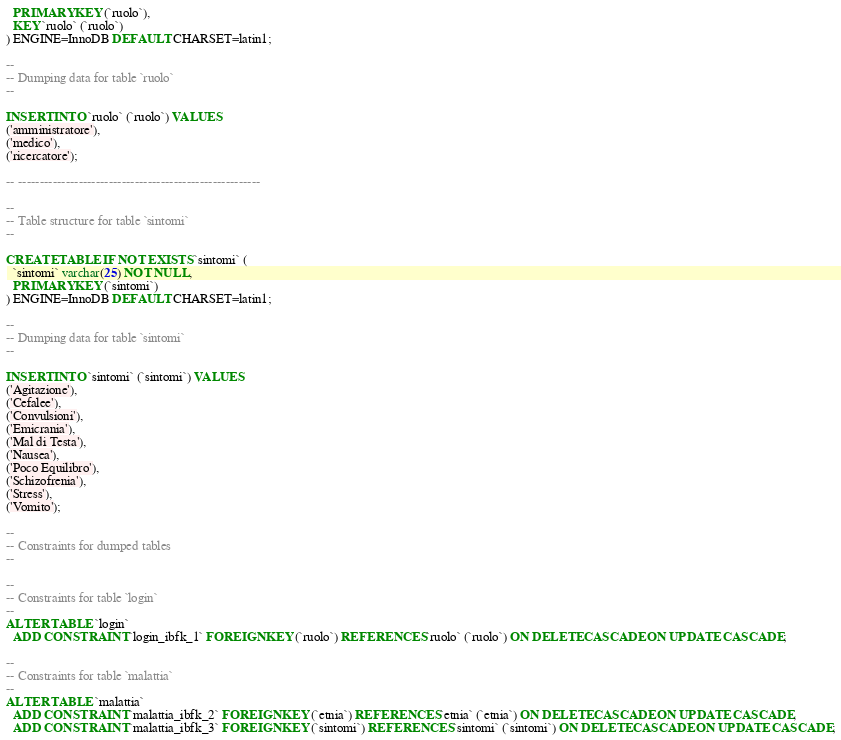<code> <loc_0><loc_0><loc_500><loc_500><_SQL_>  PRIMARY KEY (`ruolo`),
  KEY `ruolo` (`ruolo`)
) ENGINE=InnoDB DEFAULT CHARSET=latin1;

--
-- Dumping data for table `ruolo`
--

INSERT INTO `ruolo` (`ruolo`) VALUES
('amministratore'),
('medico'),
('ricercatore');

-- --------------------------------------------------------

--
-- Table structure for table `sintomi`
--

CREATE TABLE IF NOT EXISTS `sintomi` (
  `sintomi` varchar(25) NOT NULL,
  PRIMARY KEY (`sintomi`)
) ENGINE=InnoDB DEFAULT CHARSET=latin1;

--
-- Dumping data for table `sintomi`
--

INSERT INTO `sintomi` (`sintomi`) VALUES
('Agitazione'),
('Cefalee'),
('Convulsioni'),
('Emicrania'),
('Mal di Testa'),
('Nausea'),
('Poco Equilibro'),
('Schizofrenia'),
('Stress'),
('Vomito');

--
-- Constraints for dumped tables
--

--
-- Constraints for table `login`
--
ALTER TABLE `login`
  ADD CONSTRAINT `login_ibfk_1` FOREIGN KEY (`ruolo`) REFERENCES `ruolo` (`ruolo`) ON DELETE CASCADE ON UPDATE CASCADE;

--
-- Constraints for table `malattia`
--
ALTER TABLE `malattia`
  ADD CONSTRAINT `malattia_ibfk_2` FOREIGN KEY (`etnia`) REFERENCES `etnia` (`etnia`) ON DELETE CASCADE ON UPDATE CASCADE,
  ADD CONSTRAINT `malattia_ibfk_3` FOREIGN KEY (`sintomi`) REFERENCES `sintomi` (`sintomi`) ON DELETE CASCADE ON UPDATE CASCADE;
</code> 